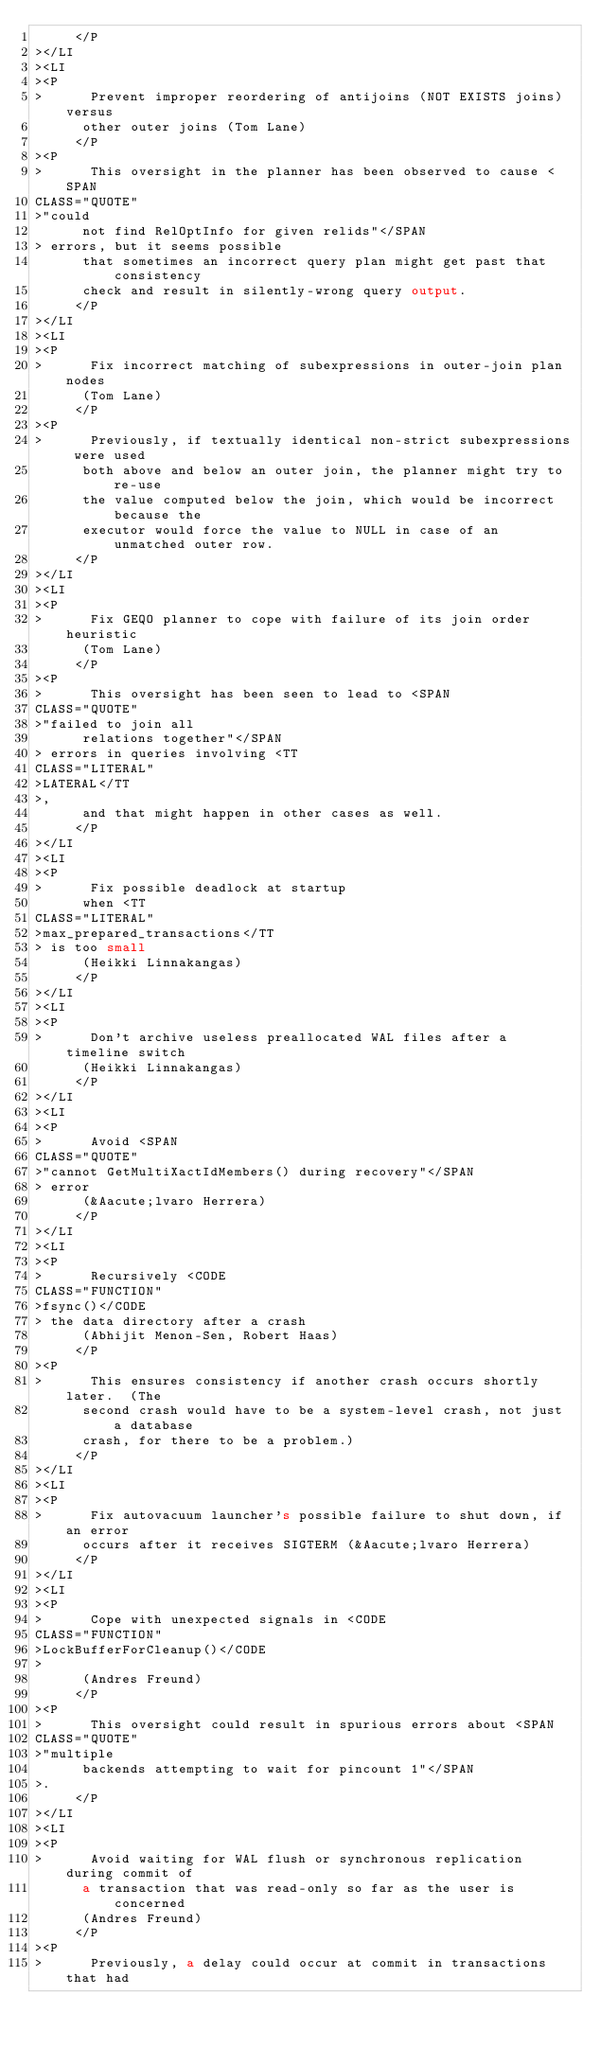<code> <loc_0><loc_0><loc_500><loc_500><_HTML_>     </P
></LI
><LI
><P
>      Prevent improper reordering of antijoins (NOT EXISTS joins) versus
      other outer joins (Tom Lane)
     </P
><P
>      This oversight in the planner has been observed to cause <SPAN
CLASS="QUOTE"
>"could
      not find RelOptInfo for given relids"</SPAN
> errors, but it seems possible
      that sometimes an incorrect query plan might get past that consistency
      check and result in silently-wrong query output.
     </P
></LI
><LI
><P
>      Fix incorrect matching of subexpressions in outer-join plan nodes
      (Tom Lane)
     </P
><P
>      Previously, if textually identical non-strict subexpressions were used
      both above and below an outer join, the planner might try to re-use
      the value computed below the join, which would be incorrect because the
      executor would force the value to NULL in case of an unmatched outer row.
     </P
></LI
><LI
><P
>      Fix GEQO planner to cope with failure of its join order heuristic
      (Tom Lane)
     </P
><P
>      This oversight has been seen to lead to <SPAN
CLASS="QUOTE"
>"failed to join all
      relations together"</SPAN
> errors in queries involving <TT
CLASS="LITERAL"
>LATERAL</TT
>,
      and that might happen in other cases as well.
     </P
></LI
><LI
><P
>      Fix possible deadlock at startup
      when <TT
CLASS="LITERAL"
>max_prepared_transactions</TT
> is too small
      (Heikki Linnakangas)
     </P
></LI
><LI
><P
>      Don't archive useless preallocated WAL files after a timeline switch
      (Heikki Linnakangas)
     </P
></LI
><LI
><P
>      Avoid <SPAN
CLASS="QUOTE"
>"cannot GetMultiXactIdMembers() during recovery"</SPAN
> error
      (&Aacute;lvaro Herrera)
     </P
></LI
><LI
><P
>      Recursively <CODE
CLASS="FUNCTION"
>fsync()</CODE
> the data directory after a crash
      (Abhijit Menon-Sen, Robert Haas)
     </P
><P
>      This ensures consistency if another crash occurs shortly later.  (The
      second crash would have to be a system-level crash, not just a database
      crash, for there to be a problem.)
     </P
></LI
><LI
><P
>      Fix autovacuum launcher's possible failure to shut down, if an error
      occurs after it receives SIGTERM (&Aacute;lvaro Herrera)
     </P
></LI
><LI
><P
>      Cope with unexpected signals in <CODE
CLASS="FUNCTION"
>LockBufferForCleanup()</CODE
>
      (Andres Freund)
     </P
><P
>      This oversight could result in spurious errors about <SPAN
CLASS="QUOTE"
>"multiple
      backends attempting to wait for pincount 1"</SPAN
>.
     </P
></LI
><LI
><P
>      Avoid waiting for WAL flush or synchronous replication during commit of
      a transaction that was read-only so far as the user is concerned
      (Andres Freund)
     </P
><P
>      Previously, a delay could occur at commit in transactions that had</code> 